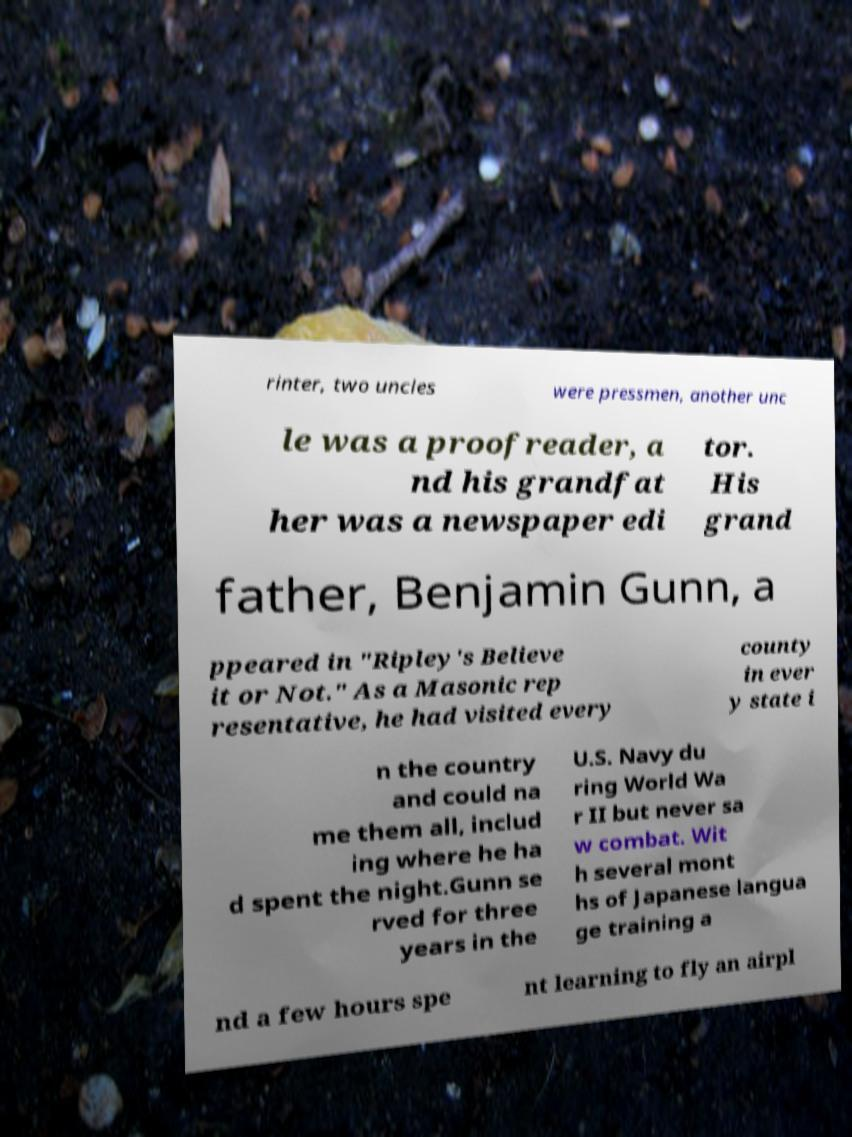Can you accurately transcribe the text from the provided image for me? rinter, two uncles were pressmen, another unc le was a proofreader, a nd his grandfat her was a newspaper edi tor. His grand father, Benjamin Gunn, a ppeared in "Ripley's Believe it or Not." As a Masonic rep resentative, he had visited every county in ever y state i n the country and could na me them all, includ ing where he ha d spent the night.Gunn se rved for three years in the U.S. Navy du ring World Wa r II but never sa w combat. Wit h several mont hs of Japanese langua ge training a nd a few hours spe nt learning to fly an airpl 